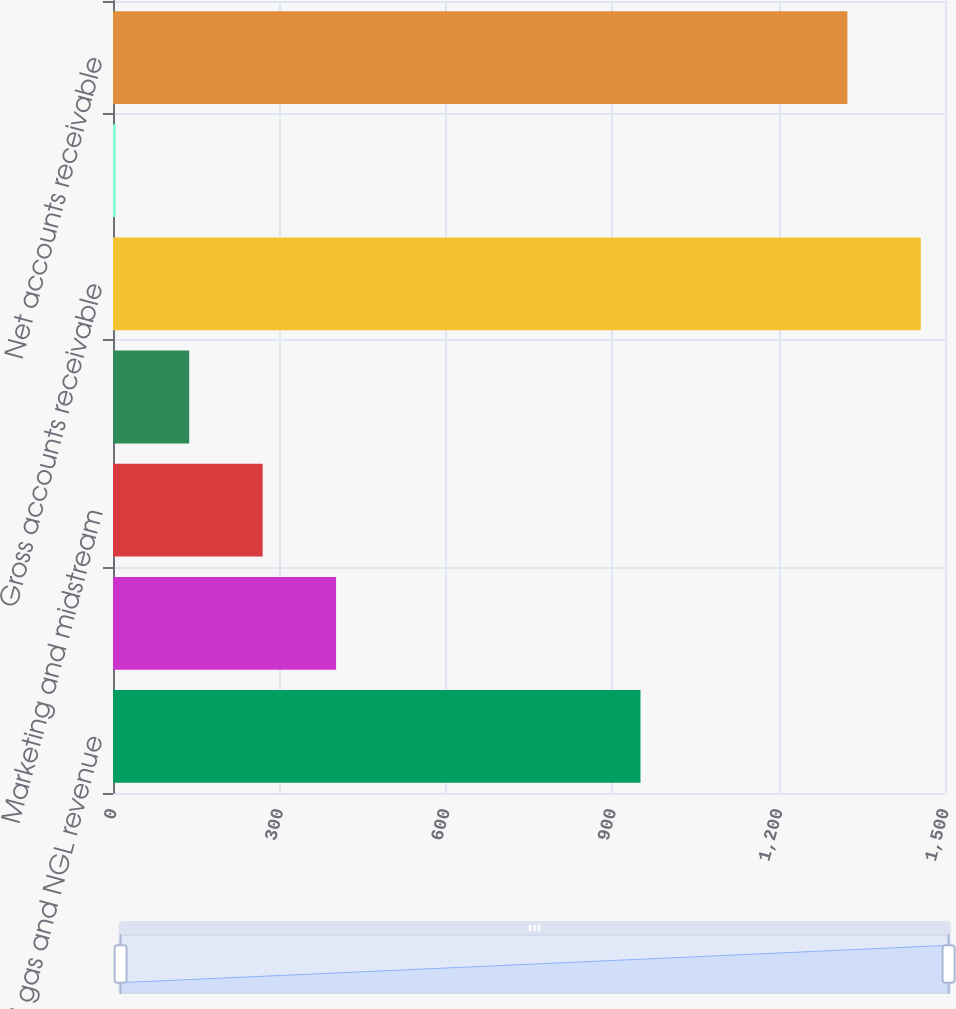Convert chart. <chart><loc_0><loc_0><loc_500><loc_500><bar_chart><fcel>Oil gas and NGL revenue<fcel>Joint interest billings<fcel>Marketing and midstream<fcel>Other<fcel>Gross accounts receivable<fcel>Allowance for doubtful<fcel>Net accounts receivable<nl><fcel>951<fcel>402.2<fcel>269.8<fcel>137.4<fcel>1456.4<fcel>5<fcel>1324<nl></chart> 